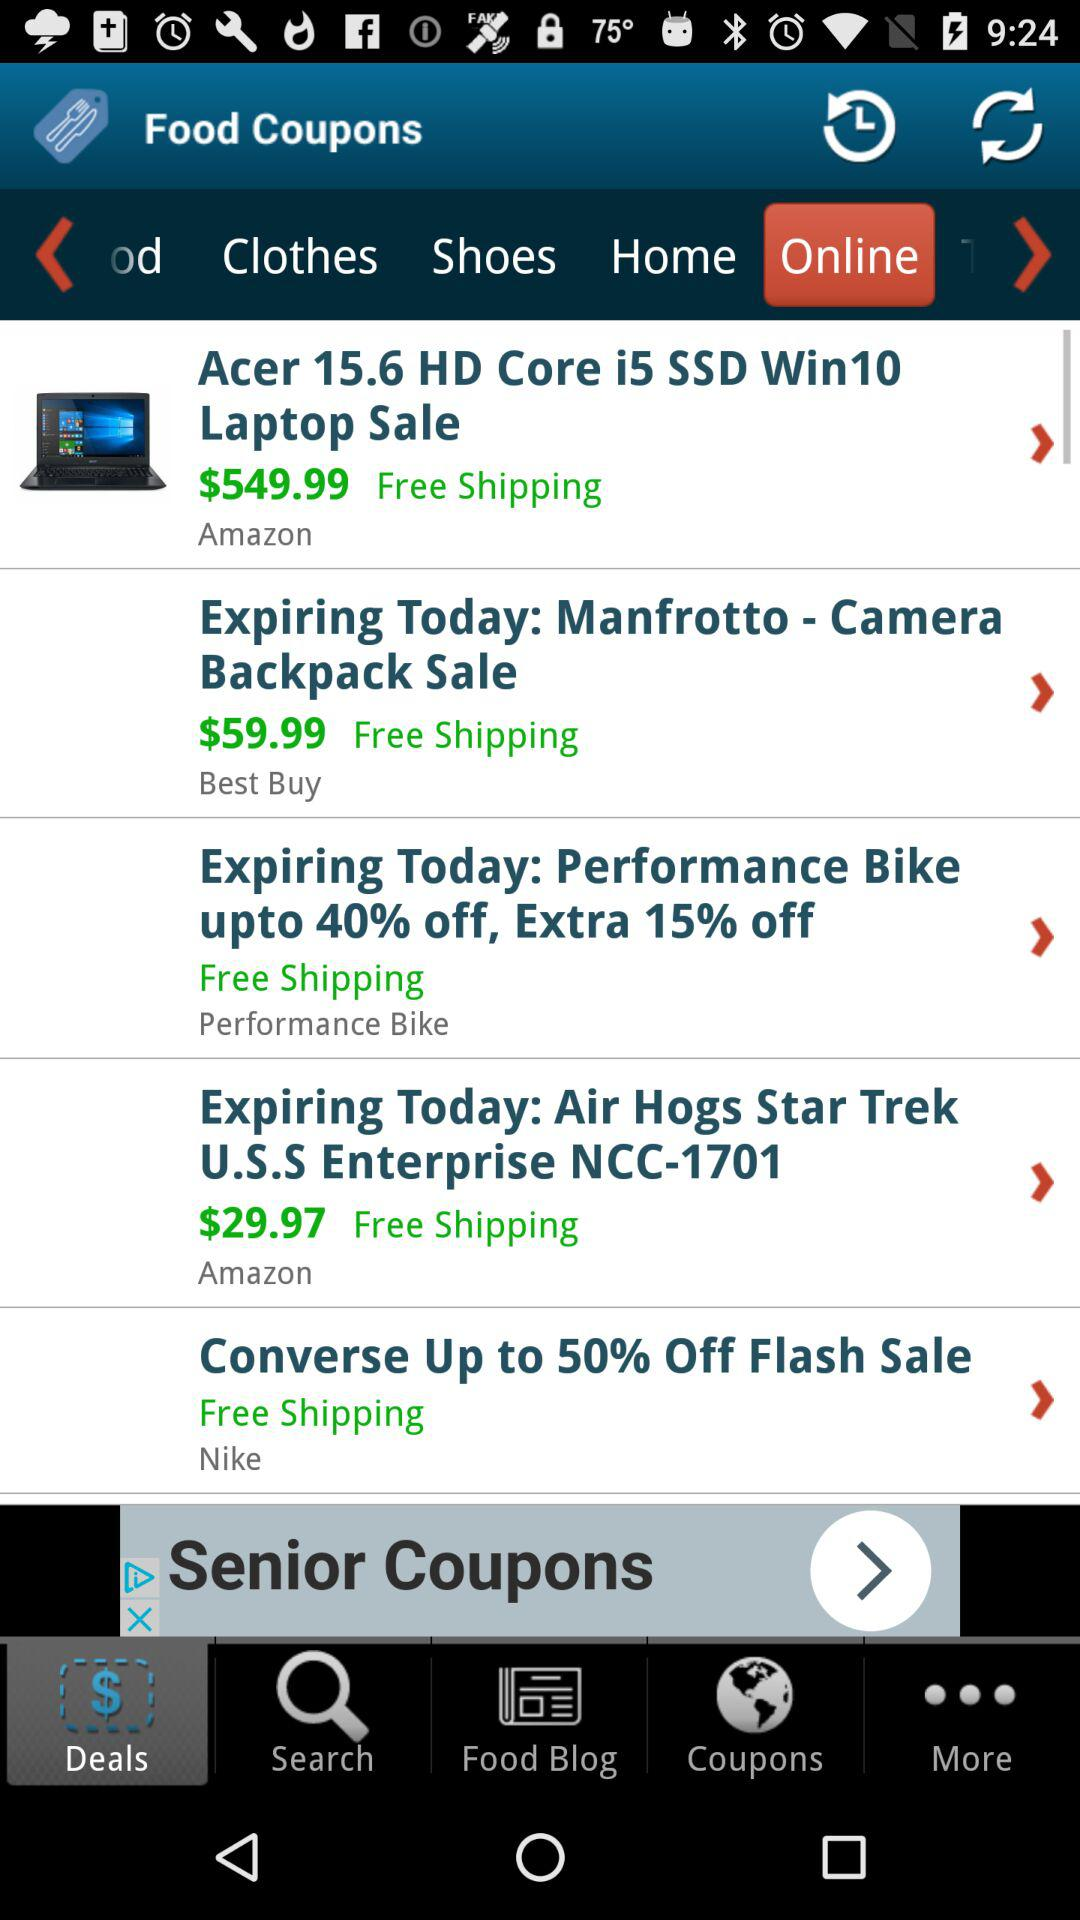When is the last day for the sale of performance bikes? The sale of performance bikes is expiring today. 